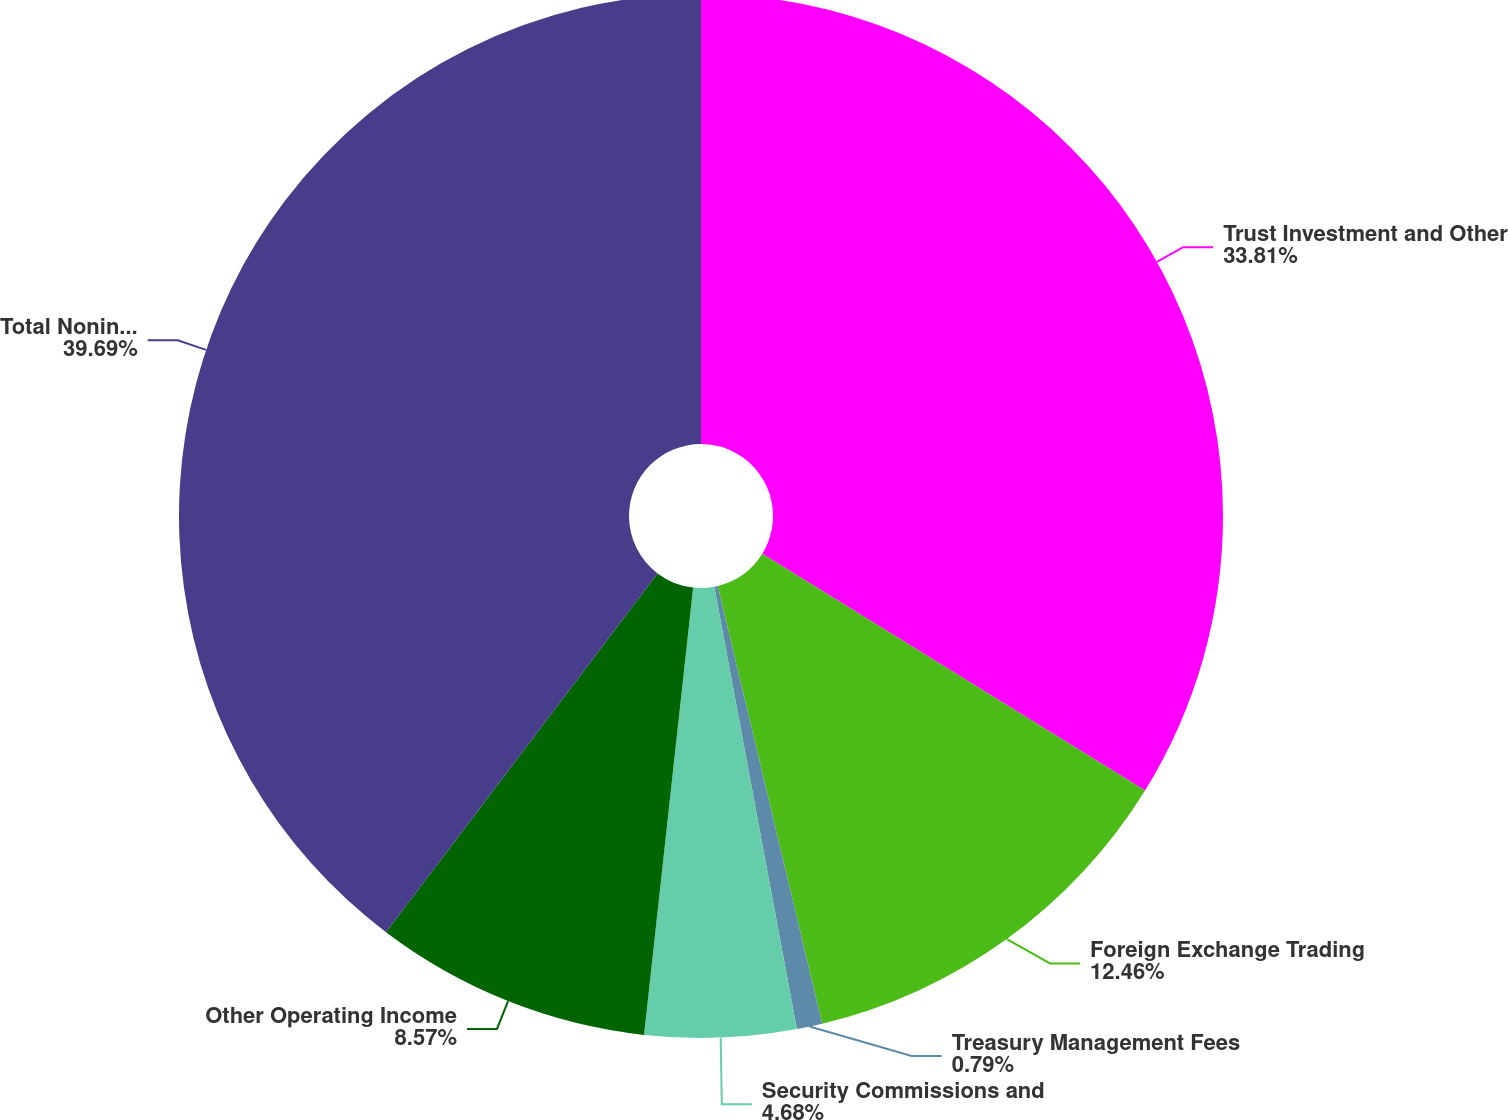<chart> <loc_0><loc_0><loc_500><loc_500><pie_chart><fcel>Trust Investment and Other<fcel>Foreign Exchange Trading<fcel>Treasury Management Fees<fcel>Security Commissions and<fcel>Other Operating Income<fcel>Total Noninterest Income<nl><fcel>33.81%<fcel>12.46%<fcel>0.79%<fcel>4.68%<fcel>8.57%<fcel>39.69%<nl></chart> 